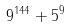<formula> <loc_0><loc_0><loc_500><loc_500>9 ^ { 1 4 4 } + 5 ^ { 9 }</formula> 